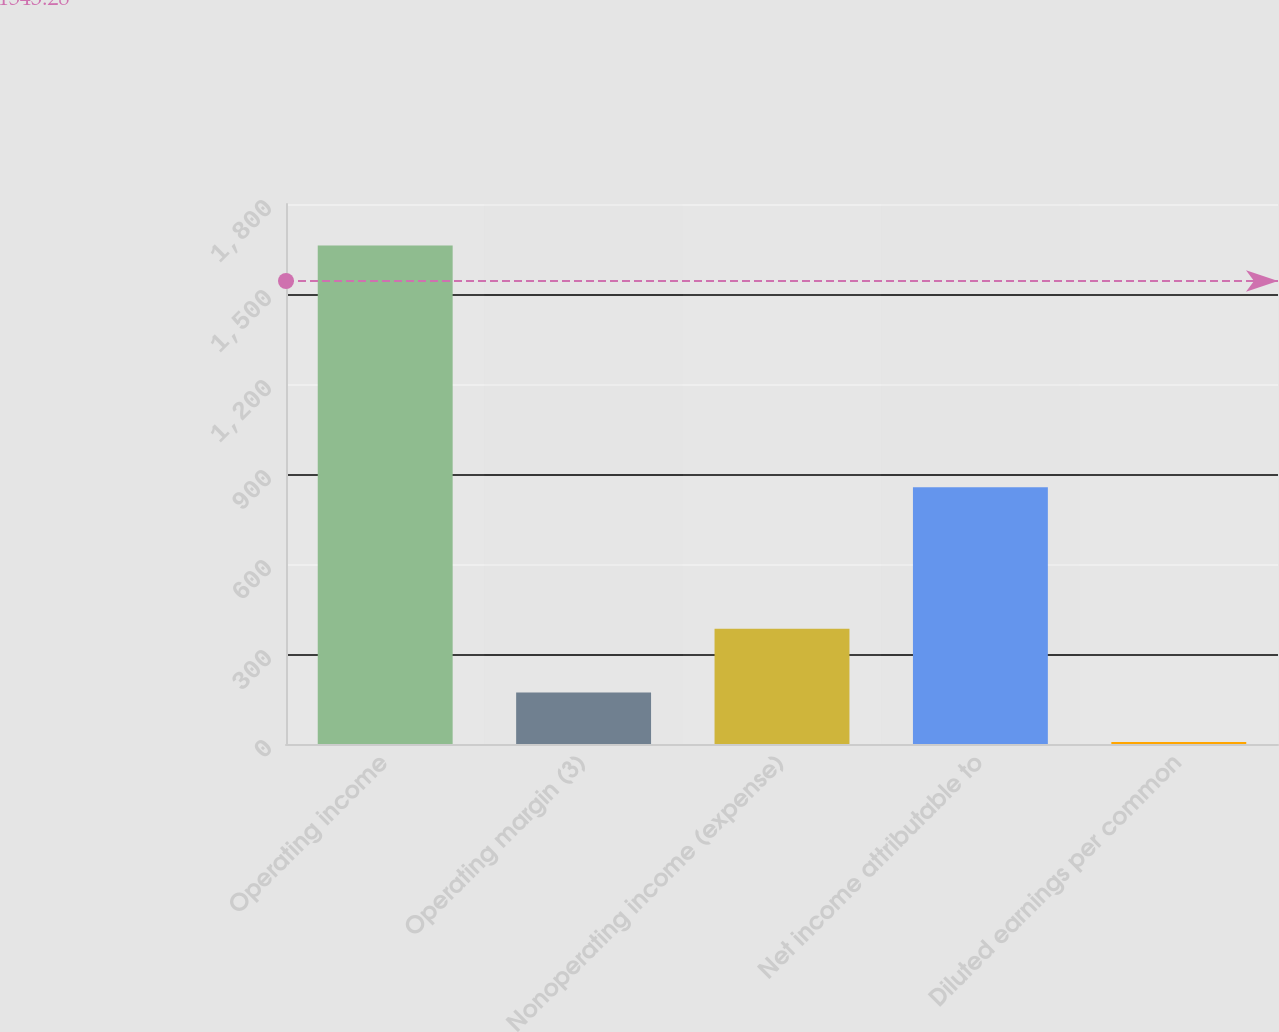Convert chart. <chart><loc_0><loc_0><loc_500><loc_500><bar_chart><fcel>Operating income<fcel>Operating margin (3)<fcel>Nonoperating income (expense)<fcel>Net income attributable to<fcel>Diluted earnings per common<nl><fcel>1662<fcel>171.87<fcel>384<fcel>856<fcel>6.3<nl></chart> 